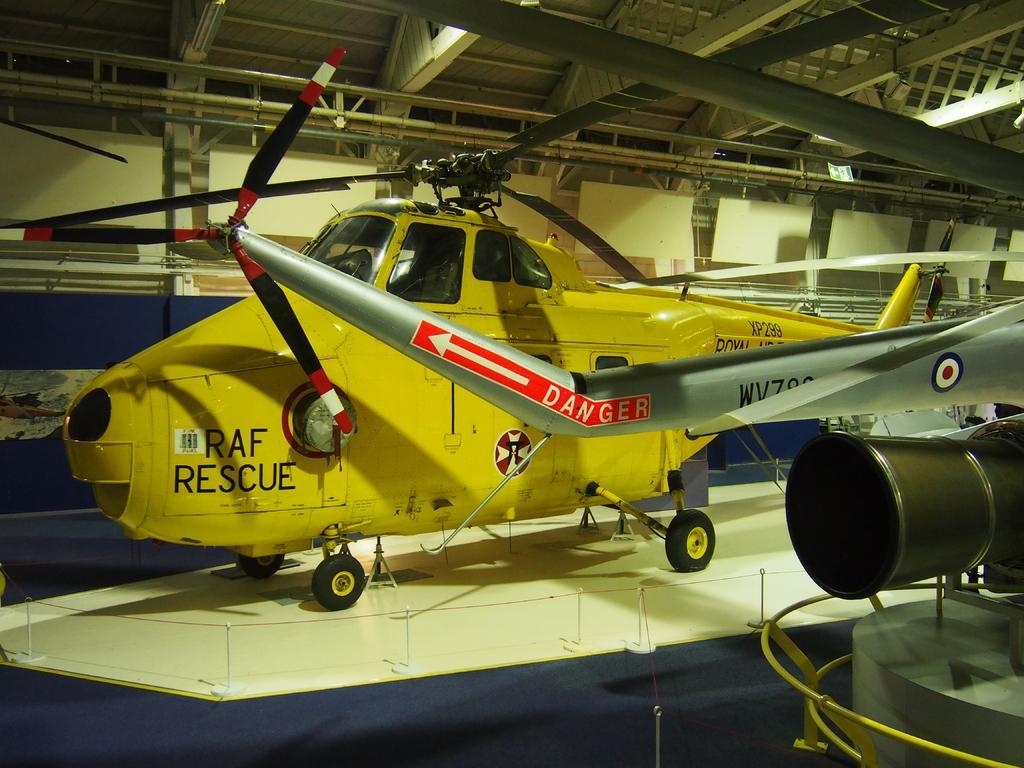How would you summarize this image in a sentence or two? In this image there are so many planes on the floor and iron roof at the top. 